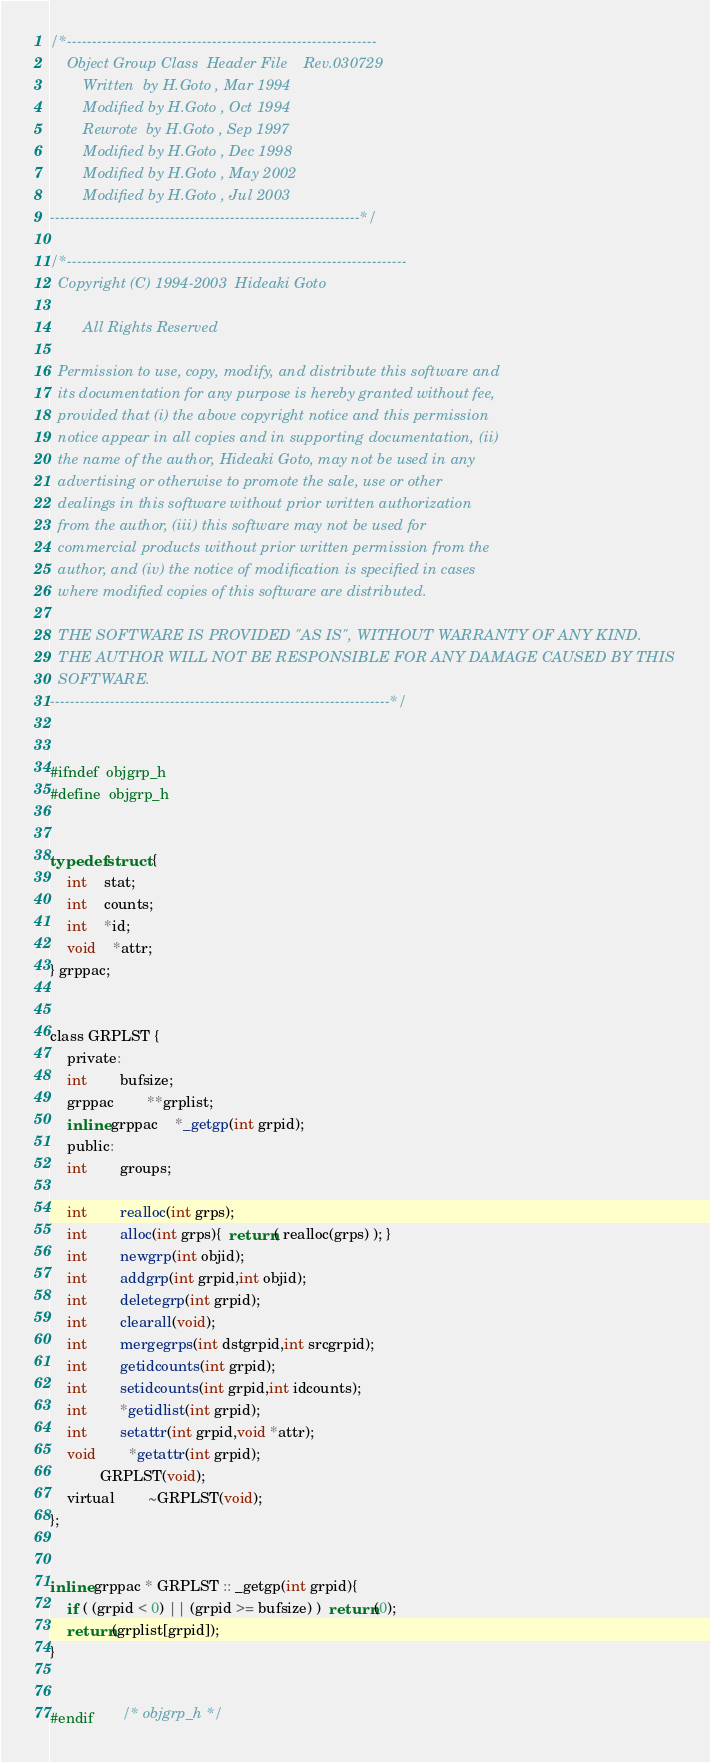<code> <loc_0><loc_0><loc_500><loc_500><_C_>/*--------------------------------------------------------------
	Object Group Class  Header File    Rev.030729
		Written  by H.Goto , Mar 1994
		Modified by H.Goto , Oct 1994
		Rewrote  by H.Goto , Sep 1997
		Modified by H.Goto , Dec 1998
		Modified by H.Goto , May 2002
		Modified by H.Goto , Jul 2003
--------------------------------------------------------------*/

/*--------------------------------------------------------------------
  Copyright (C) 1994-2003  Hideaki Goto

        All Rights Reserved

  Permission to use, copy, modify, and distribute this software and
  its documentation for any purpose is hereby granted without fee,
  provided that (i) the above copyright notice and this permission
  notice appear in all copies and in supporting documentation, (ii)
  the name of the author, Hideaki Goto, may not be used in any
  advertising or otherwise to promote the sale, use or other
  dealings in this software without prior written authorization
  from the author, (iii) this software may not be used for
  commercial products without prior written permission from the
  author, and (iv) the notice of modification is specified in cases
  where modified copies of this software are distributed.

  THE SOFTWARE IS PROVIDED "AS IS", WITHOUT WARRANTY OF ANY KIND.
  THE AUTHOR WILL NOT BE RESPONSIBLE FOR ANY DAMAGE CAUSED BY THIS
  SOFTWARE.
--------------------------------------------------------------------*/


#ifndef	objgrp_h
#define	objgrp_h


typedef struct {
	int	stat;
	int	counts;
	int	*id;
	void	*attr;
} grppac;


class GRPLST {
    private:
	int		bufsize;
	grppac		**grplist;
	inline grppac	*_getgp(int grpid);
    public:
	int		groups;

	int		realloc(int grps);
	int		alloc(int grps){  return( realloc(grps) ); }
	int		newgrp(int objid);
	int		addgrp(int grpid,int objid);
	int		deletegrp(int grpid);
	int		clearall(void);
	int		mergegrps(int dstgrpid,int srcgrpid);
	int		getidcounts(int grpid);
	int		setidcounts(int grpid,int idcounts);
	int		*getidlist(int grpid);
	int		setattr(int grpid,void *attr);
	void		*getattr(int grpid);
			GRPLST(void);
	virtual		~GRPLST(void);
};


inline grppac * GRPLST :: _getgp(int grpid){
	if ( (grpid < 0) || (grpid >= bufsize) )  return(0);
	return(grplist[grpid]);
}


#endif		/* objgrp_h */
</code> 